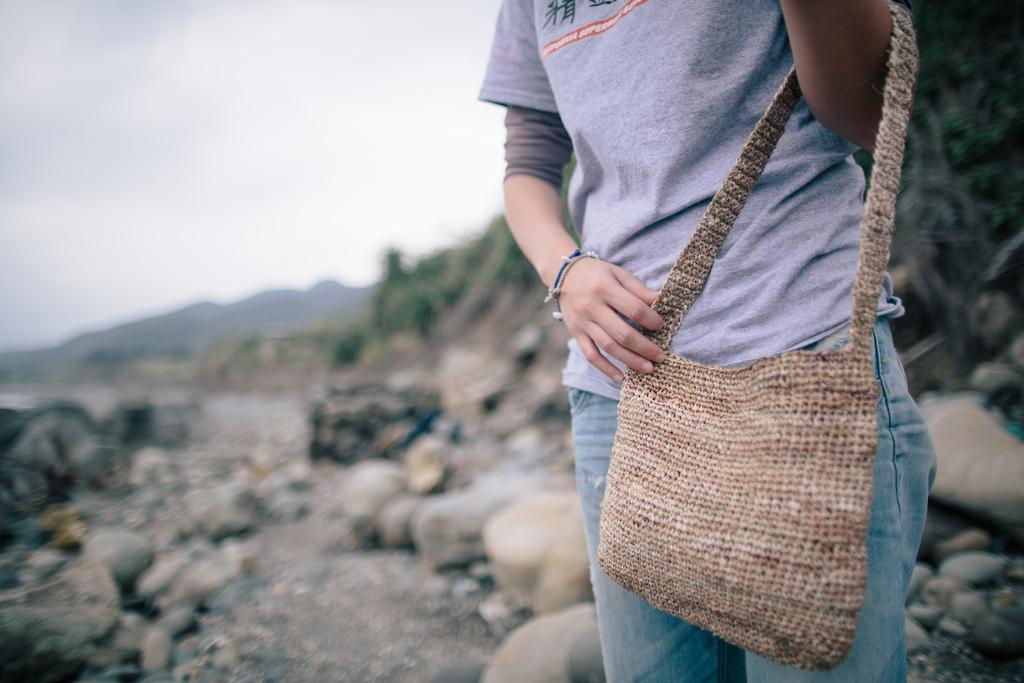Who is present in the image? There is a woman in the image. What is the woman holding in the image? The woman is holding a bag. What type of natural features can be seen in the image? There are rocks and hills in the image. What part of the environment is visible in the image? The sky is visible in the image. What is the title of the book the woman is reading in the image? There is no book present in the image, so it is not possible to determine the title. 